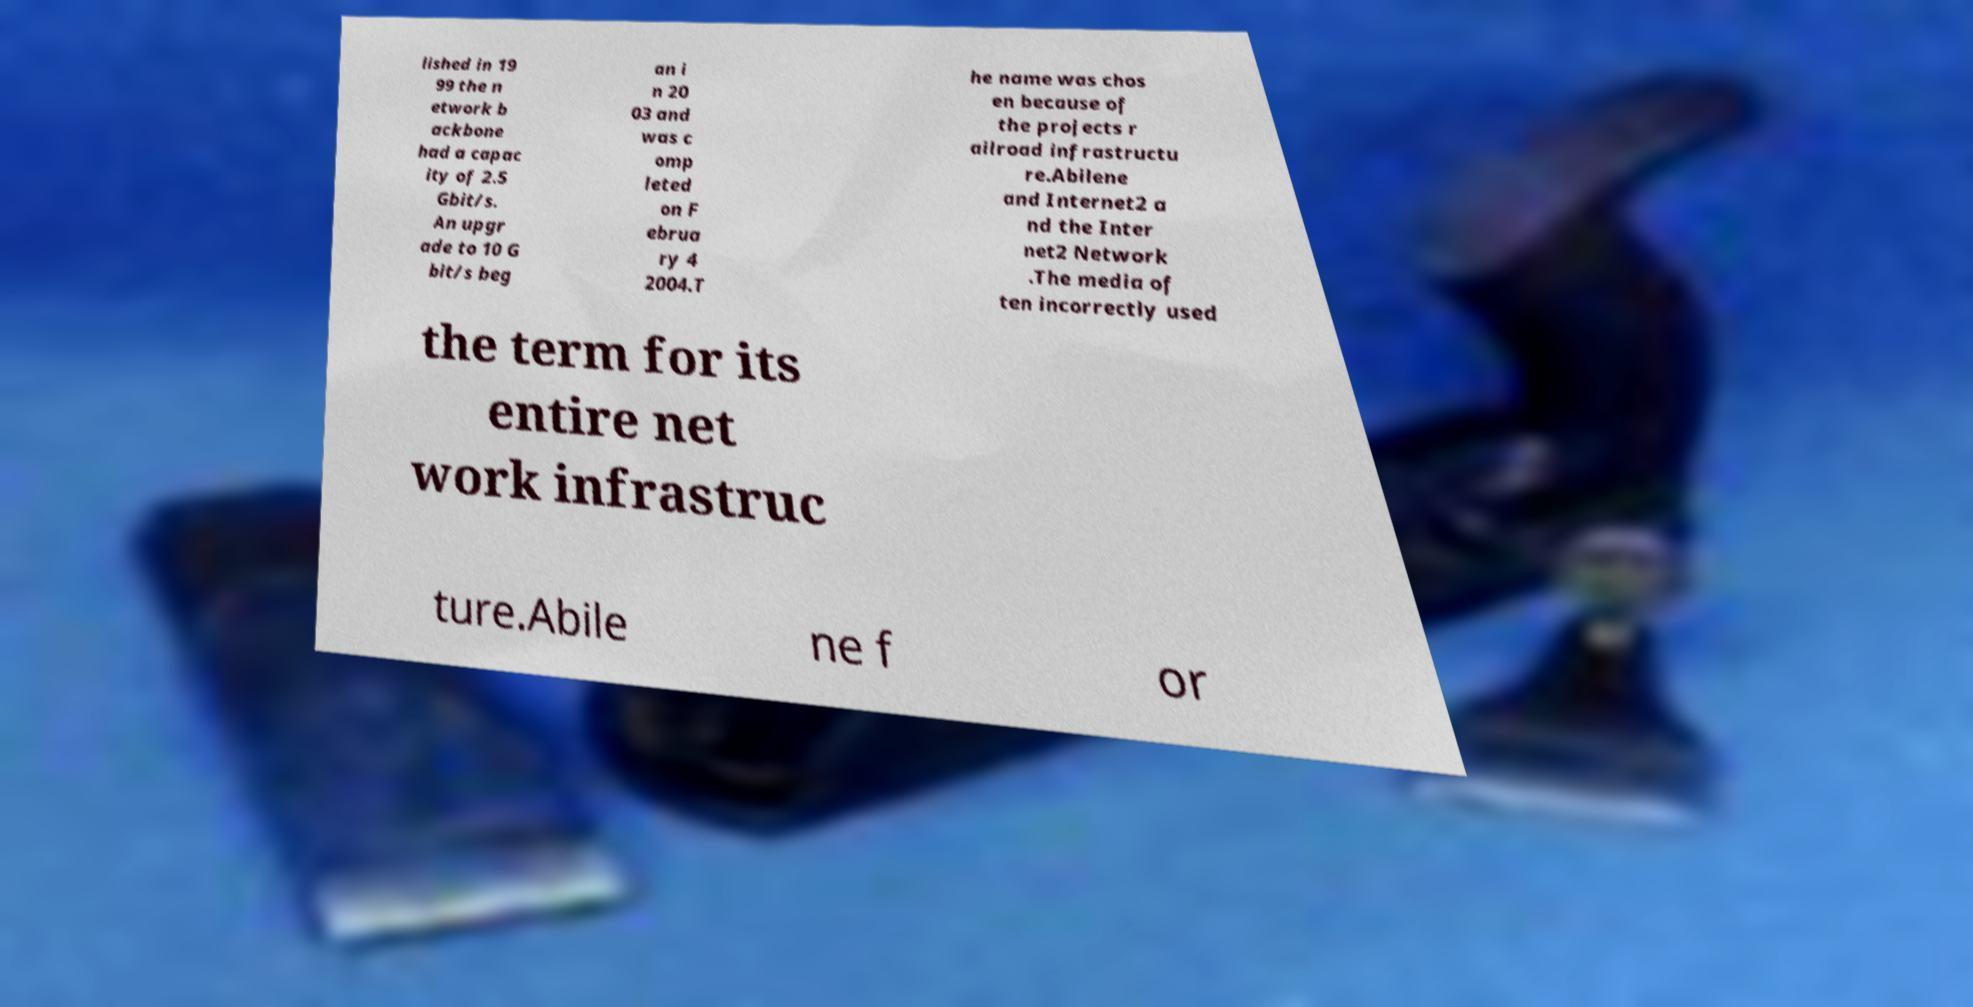What messages or text are displayed in this image? I need them in a readable, typed format. lished in 19 99 the n etwork b ackbone had a capac ity of 2.5 Gbit/s. An upgr ade to 10 G bit/s beg an i n 20 03 and was c omp leted on F ebrua ry 4 2004.T he name was chos en because of the projects r ailroad infrastructu re.Abilene and Internet2 a nd the Inter net2 Network .The media of ten incorrectly used the term for its entire net work infrastruc ture.Abile ne f or 